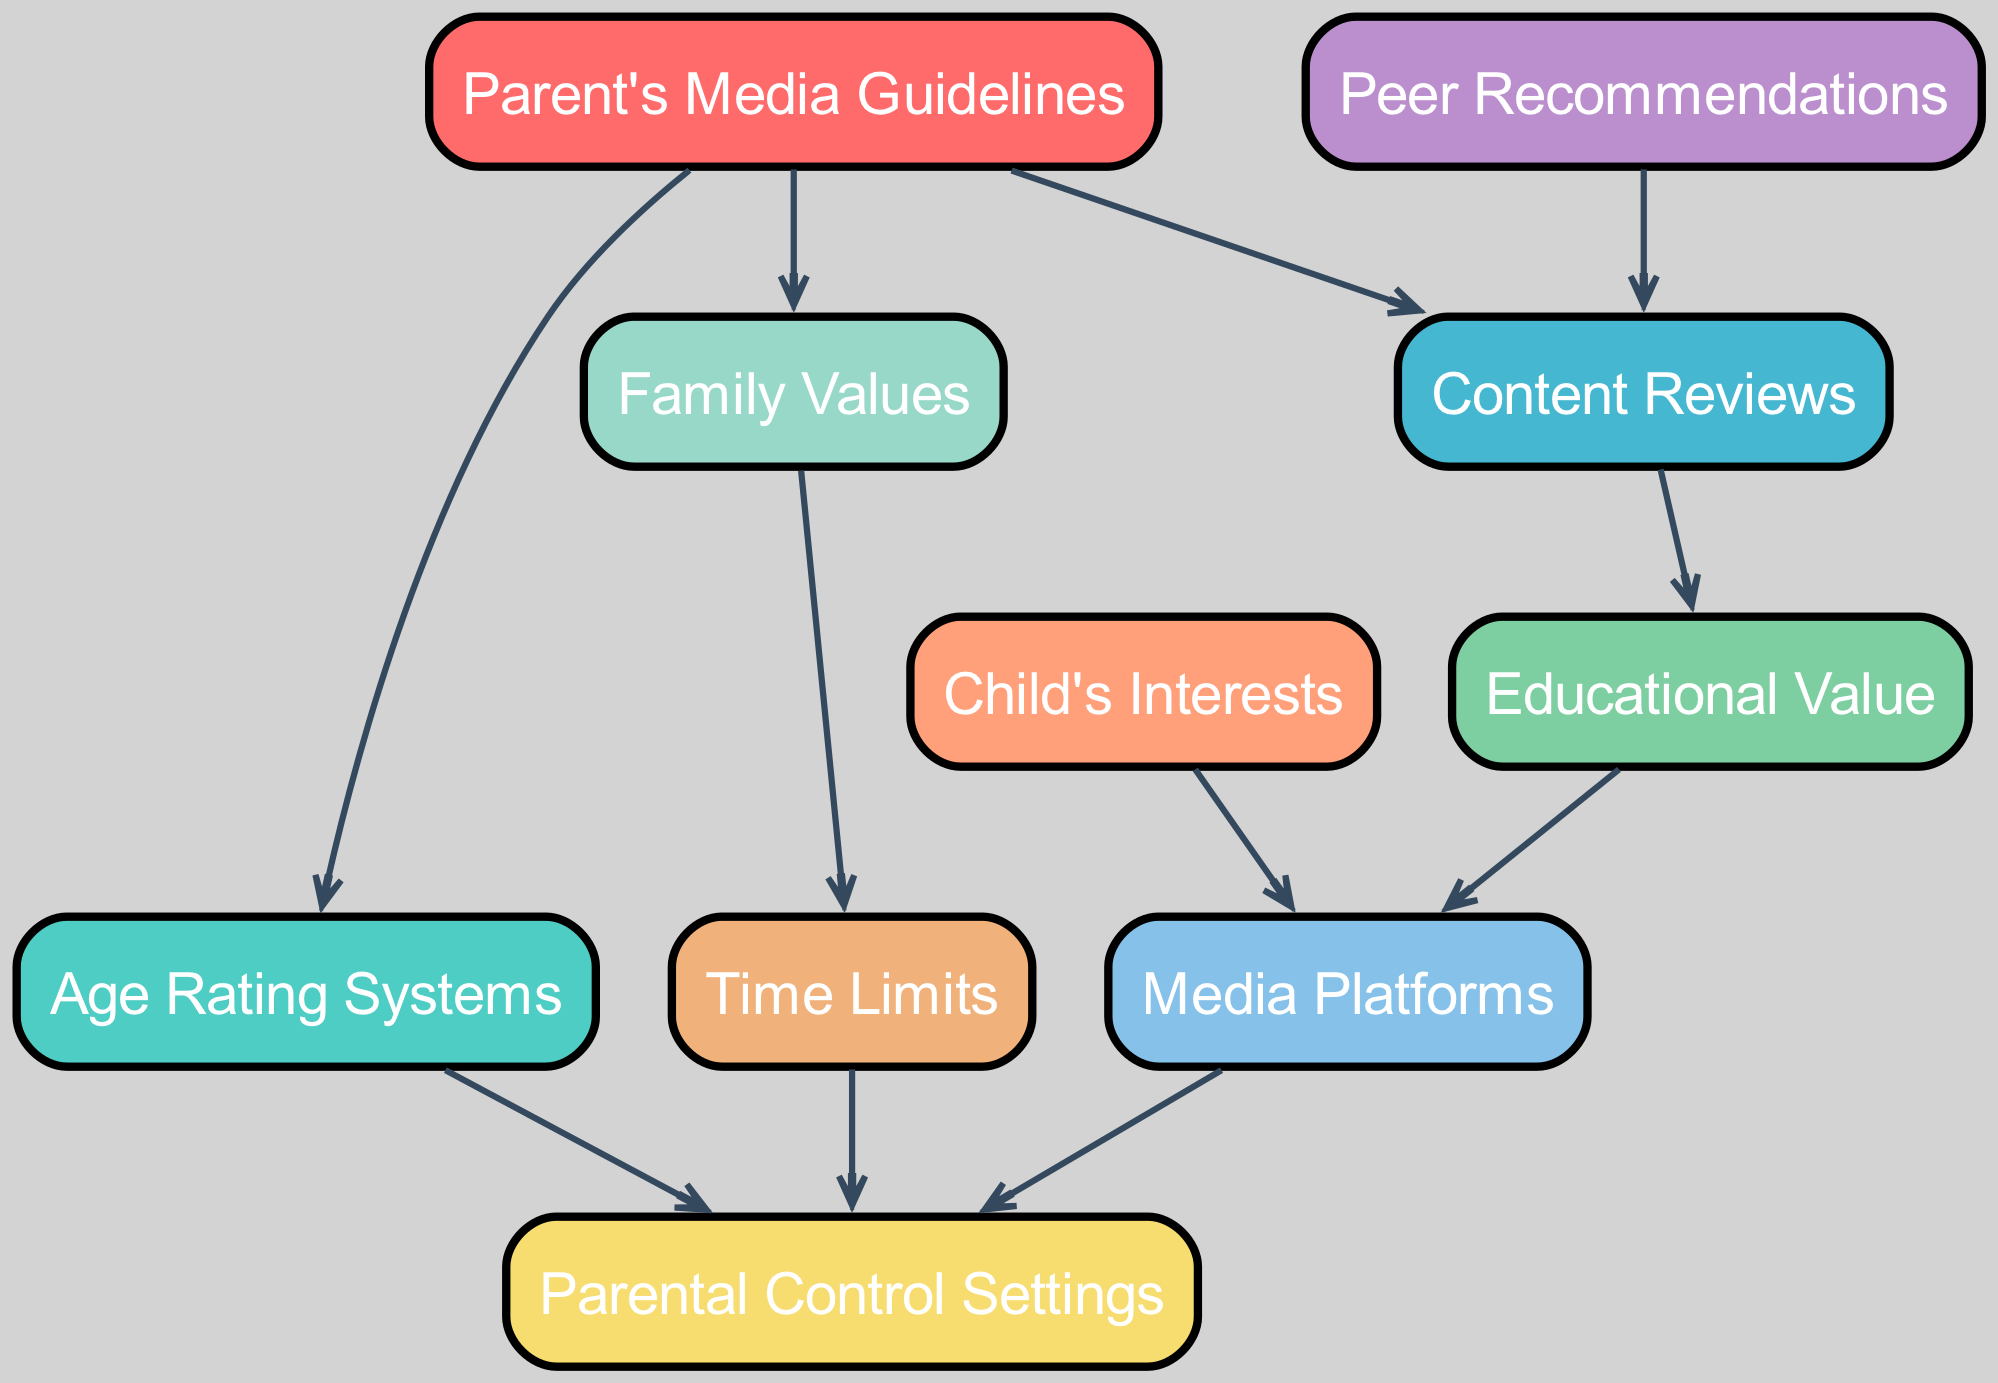What nodes are connected to "Parent's Media Guidelines"? The nodes directly connected to "Parent's Media Guidelines" are "Age Rating Systems," "Content Reviews," and "Family Values." By examining the edges leading from "Parent's Media Guidelines," we can see it's connected to three specific nodes.
Answer: Age Rating Systems, Content Reviews, Family Values How many total nodes are in the diagram? The diagram contains 10 nodes, which can be counted directly from the list provided in the data. Each unique item listed corresponds to one node in the graph.
Answer: 10 Which node is influenced by both "Family Values" and "Content Reviews"? "Parental Control Settings" is the node that is influenced by two distinct nodes: "Family Values," which connects to it, and "Time Limits," which influences it too. This indicates combined considerations in parental control.
Answer: Parental Control Settings What type of value do "Content Reviews" contribute to? "Educational Value" derives from "Content Reviews," which connects directly to it. This suggests that reviews are aimed at assessing and enhancing educational content's quality for children.
Answer: Educational Value What is the relationship between "Child's Interests" and "Media Platforms"? "Child's Interests" leads to "Media Platforms," meaning that a child's specific interests inform which platforms are deemed suitable for them based on the available media they enjoy.
Answer: Inspired Which node acts as a filter before reaching "Media Platforms"? "Educational Value" serves as a filter to determine suitable types of media before moving onto "Media Platforms." Thus, the educational assessment precedes platform selection.
Answer: Educational Value How does "Peer Recommendations" interact with "Content Reviews"? "Peer Recommendations" directly influences "Content Reviews," indicating that suggestions from peers can enhance the assessment of media through reviews that evaluate content quality.
Answer: Influences What effect do "Time Limits" have in the diagram? "Time Limits" connects to "Parental Control Settings," indicating that the management of time children spend on media directly influences the establishment of controls on usage.
Answer: Establish controls How many edges are there in the diagram? The diagram contains 10 edges, which can be counted by identifying each directed connection between the nodes listed in the data. Each connection represents a relationship that shapes the media selection process.
Answer: 10 Which node can both influence and be influenced within the diagram? "Parental Control Settings" both influences and is influenced by other nodes, highlighting its dual role in managing content based on education and family values while being shaped by them as well.
Answer: Parental Control Settings 